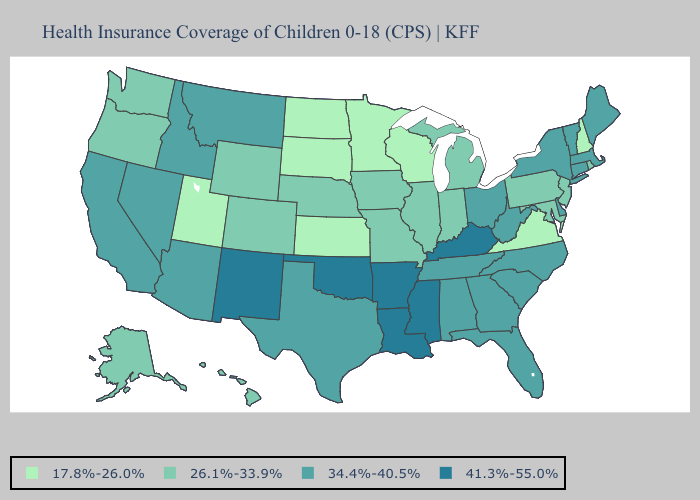Does the first symbol in the legend represent the smallest category?
Keep it brief. Yes. What is the lowest value in the Northeast?
Keep it brief. 17.8%-26.0%. Does Connecticut have the lowest value in the Northeast?
Answer briefly. No. Name the states that have a value in the range 41.3%-55.0%?
Write a very short answer. Arkansas, Kentucky, Louisiana, Mississippi, New Mexico, Oklahoma. Does Pennsylvania have a higher value than South Dakota?
Be succinct. Yes. What is the value of Pennsylvania?
Be succinct. 26.1%-33.9%. What is the value of Georgia?
Keep it brief. 34.4%-40.5%. Name the states that have a value in the range 26.1%-33.9%?
Give a very brief answer. Alaska, Colorado, Hawaii, Illinois, Indiana, Iowa, Maryland, Michigan, Missouri, Nebraska, New Jersey, Oregon, Pennsylvania, Rhode Island, Washington, Wyoming. Among the states that border South Dakota , which have the lowest value?
Write a very short answer. Minnesota, North Dakota. What is the value of Wyoming?
Be succinct. 26.1%-33.9%. What is the value of New York?
Keep it brief. 34.4%-40.5%. What is the highest value in the USA?
Write a very short answer. 41.3%-55.0%. Does Indiana have the lowest value in the USA?
Quick response, please. No. What is the highest value in the USA?
Write a very short answer. 41.3%-55.0%. 